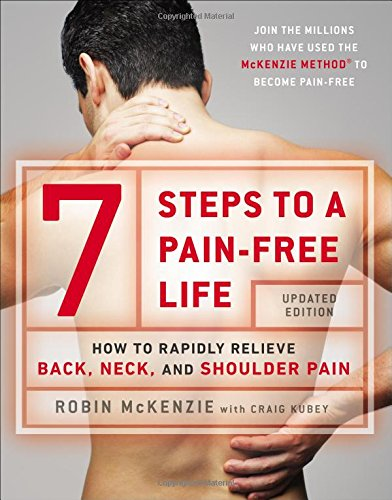Who wrote this book? The book '7 Steps to a Pain-Free Life' was authored by Robin McKenzie, a renowned physiotherapist known for his contributions to musculoskeletal disorders treatments. 